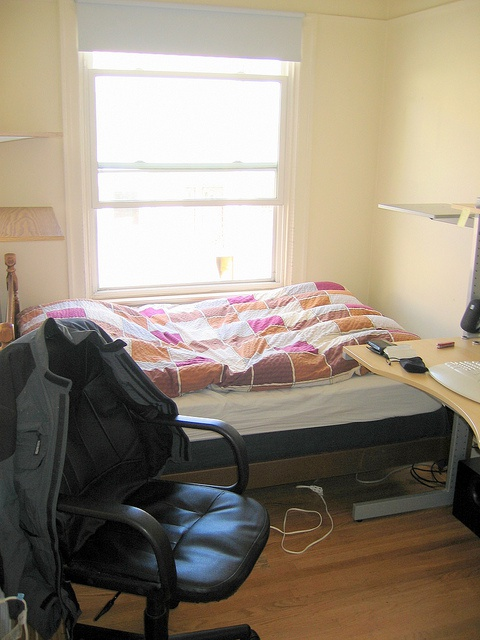Describe the objects in this image and their specific colors. I can see bed in tan, black, lightgray, darkgray, and lightpink tones, chair in tan, black, gray, and maroon tones, keyboard in tan and lightgray tones, and cell phone in tan, gray, black, and darkgray tones in this image. 